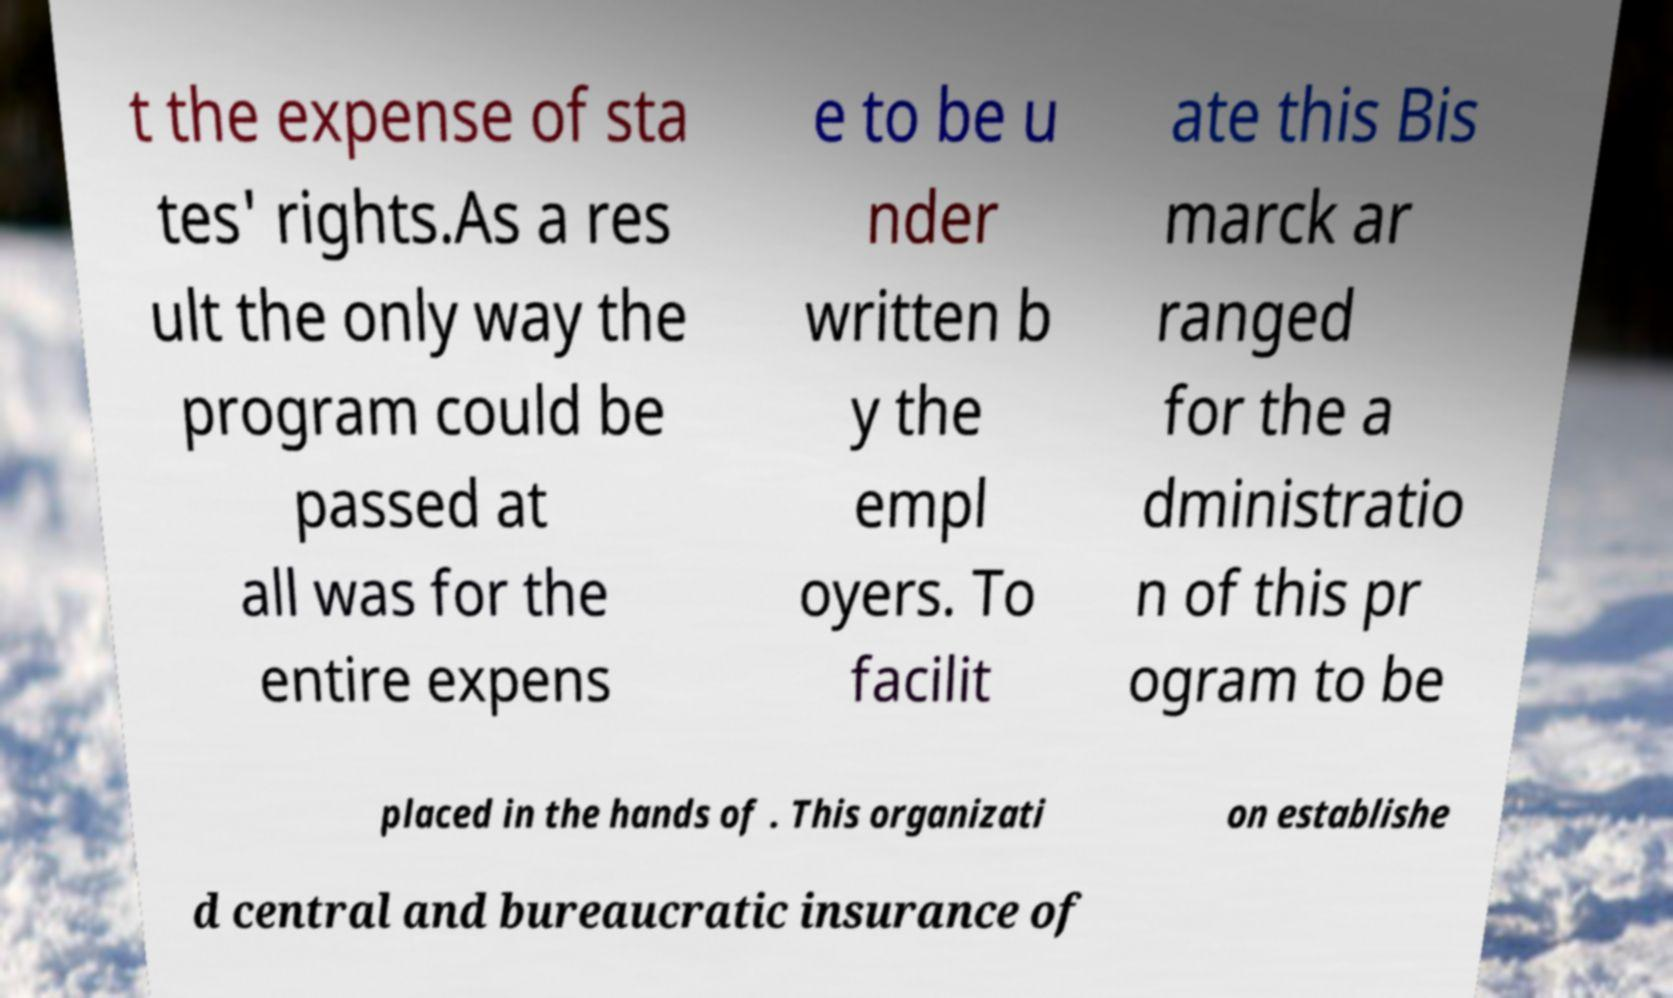Could you extract and type out the text from this image? t the expense of sta tes' rights.As a res ult the only way the program could be passed at all was for the entire expens e to be u nder written b y the empl oyers. To facilit ate this Bis marck ar ranged for the a dministratio n of this pr ogram to be placed in the hands of . This organizati on establishe d central and bureaucratic insurance of 